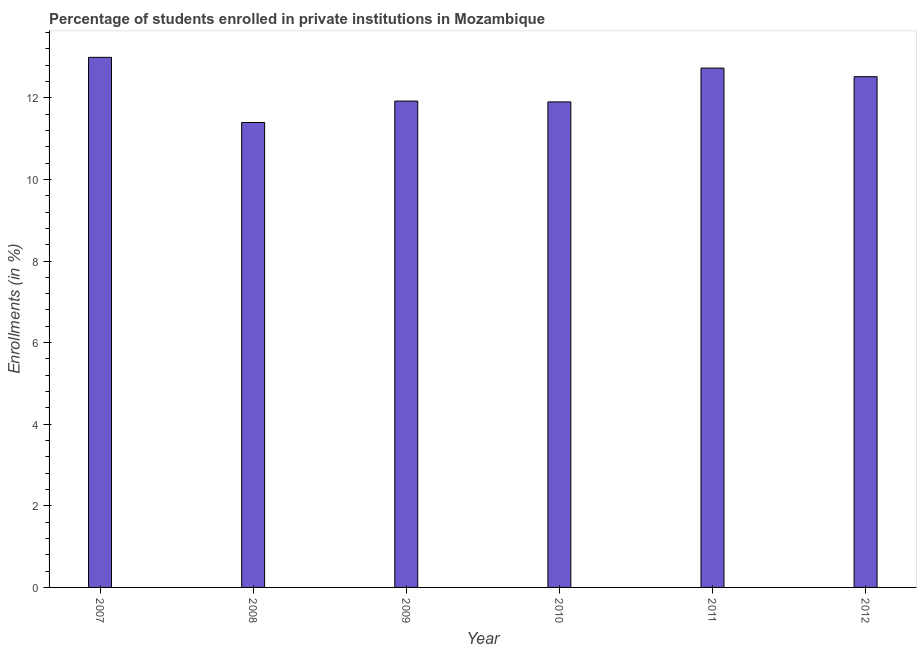Does the graph contain grids?
Offer a very short reply. No. What is the title of the graph?
Ensure brevity in your answer.  Percentage of students enrolled in private institutions in Mozambique. What is the label or title of the X-axis?
Provide a succinct answer. Year. What is the label or title of the Y-axis?
Keep it short and to the point. Enrollments (in %). What is the enrollments in private institutions in 2009?
Your answer should be compact. 11.92. Across all years, what is the maximum enrollments in private institutions?
Provide a succinct answer. 12.99. Across all years, what is the minimum enrollments in private institutions?
Provide a short and direct response. 11.39. What is the sum of the enrollments in private institutions?
Ensure brevity in your answer.  73.45. What is the difference between the enrollments in private institutions in 2008 and 2011?
Offer a very short reply. -1.33. What is the average enrollments in private institutions per year?
Your response must be concise. 12.24. What is the median enrollments in private institutions?
Your answer should be compact. 12.22. What is the ratio of the enrollments in private institutions in 2008 to that in 2009?
Provide a succinct answer. 0.96. Is the enrollments in private institutions in 2011 less than that in 2012?
Your response must be concise. No. What is the difference between the highest and the second highest enrollments in private institutions?
Keep it short and to the point. 0.26. What is the difference between the highest and the lowest enrollments in private institutions?
Keep it short and to the point. 1.6. Are all the bars in the graph horizontal?
Keep it short and to the point. No. How many years are there in the graph?
Provide a short and direct response. 6. What is the Enrollments (in %) in 2007?
Your answer should be very brief. 12.99. What is the Enrollments (in %) of 2008?
Your answer should be compact. 11.39. What is the Enrollments (in %) of 2009?
Offer a terse response. 11.92. What is the Enrollments (in %) of 2010?
Give a very brief answer. 11.9. What is the Enrollments (in %) in 2011?
Keep it short and to the point. 12.73. What is the Enrollments (in %) of 2012?
Keep it short and to the point. 12.52. What is the difference between the Enrollments (in %) in 2007 and 2008?
Your answer should be very brief. 1.6. What is the difference between the Enrollments (in %) in 2007 and 2009?
Ensure brevity in your answer.  1.07. What is the difference between the Enrollments (in %) in 2007 and 2010?
Offer a terse response. 1.09. What is the difference between the Enrollments (in %) in 2007 and 2011?
Give a very brief answer. 0.26. What is the difference between the Enrollments (in %) in 2007 and 2012?
Make the answer very short. 0.47. What is the difference between the Enrollments (in %) in 2008 and 2009?
Offer a terse response. -0.53. What is the difference between the Enrollments (in %) in 2008 and 2010?
Offer a terse response. -0.5. What is the difference between the Enrollments (in %) in 2008 and 2011?
Provide a short and direct response. -1.33. What is the difference between the Enrollments (in %) in 2008 and 2012?
Your answer should be compact. -1.12. What is the difference between the Enrollments (in %) in 2009 and 2010?
Ensure brevity in your answer.  0.02. What is the difference between the Enrollments (in %) in 2009 and 2011?
Make the answer very short. -0.81. What is the difference between the Enrollments (in %) in 2009 and 2012?
Ensure brevity in your answer.  -0.6. What is the difference between the Enrollments (in %) in 2010 and 2011?
Offer a terse response. -0.83. What is the difference between the Enrollments (in %) in 2010 and 2012?
Ensure brevity in your answer.  -0.62. What is the difference between the Enrollments (in %) in 2011 and 2012?
Offer a very short reply. 0.21. What is the ratio of the Enrollments (in %) in 2007 to that in 2008?
Offer a very short reply. 1.14. What is the ratio of the Enrollments (in %) in 2007 to that in 2009?
Your answer should be compact. 1.09. What is the ratio of the Enrollments (in %) in 2007 to that in 2010?
Make the answer very short. 1.09. What is the ratio of the Enrollments (in %) in 2007 to that in 2012?
Offer a very short reply. 1.04. What is the ratio of the Enrollments (in %) in 2008 to that in 2009?
Your answer should be very brief. 0.96. What is the ratio of the Enrollments (in %) in 2008 to that in 2010?
Ensure brevity in your answer.  0.96. What is the ratio of the Enrollments (in %) in 2008 to that in 2011?
Offer a very short reply. 0.9. What is the ratio of the Enrollments (in %) in 2008 to that in 2012?
Ensure brevity in your answer.  0.91. What is the ratio of the Enrollments (in %) in 2009 to that in 2011?
Offer a very short reply. 0.94. What is the ratio of the Enrollments (in %) in 2009 to that in 2012?
Ensure brevity in your answer.  0.95. What is the ratio of the Enrollments (in %) in 2010 to that in 2011?
Make the answer very short. 0.94. What is the ratio of the Enrollments (in %) in 2010 to that in 2012?
Make the answer very short. 0.95. What is the ratio of the Enrollments (in %) in 2011 to that in 2012?
Provide a short and direct response. 1.02. 